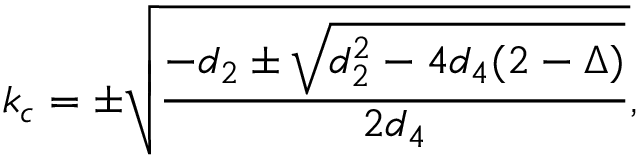<formula> <loc_0><loc_0><loc_500><loc_500>k _ { c } = \pm \sqrt { \frac { - d _ { 2 } \pm \sqrt { d _ { 2 } ^ { 2 } - 4 d _ { 4 } ( 2 - \Delta ) } } { 2 d _ { 4 } } } ,</formula> 